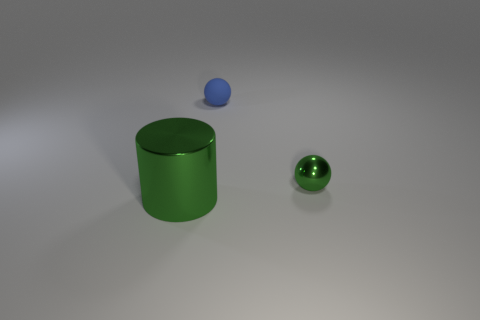Add 3 tiny shiny things. How many objects exist? 6 Subtract all cylinders. How many objects are left? 2 Subtract all yellow balls. How many brown cylinders are left? 0 Subtract all small red metal objects. Subtract all green shiny cylinders. How many objects are left? 2 Add 3 big green cylinders. How many big green cylinders are left? 4 Add 3 small blue things. How many small blue things exist? 4 Subtract 0 brown cylinders. How many objects are left? 3 Subtract 1 balls. How many balls are left? 1 Subtract all green balls. Subtract all yellow cylinders. How many balls are left? 1 